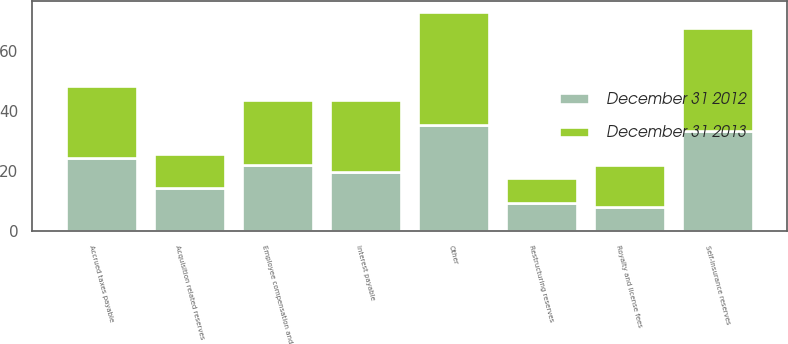Convert chart to OTSL. <chart><loc_0><loc_0><loc_500><loc_500><stacked_bar_chart><ecel><fcel>Employee compensation and<fcel>Self-insurance reserves<fcel>Accrued taxes payable<fcel>Royalty and license fees<fcel>Restructuring reserves<fcel>Acquisition related reserves<fcel>Interest payable<fcel>Other<nl><fcel>December 31 2012<fcel>21.85<fcel>33.3<fcel>24.2<fcel>8.1<fcel>9.3<fcel>14.2<fcel>19.7<fcel>35.2<nl><fcel>December 31 2013<fcel>21.85<fcel>34.2<fcel>24<fcel>13.8<fcel>8.4<fcel>11.5<fcel>24<fcel>37.7<nl></chart> 